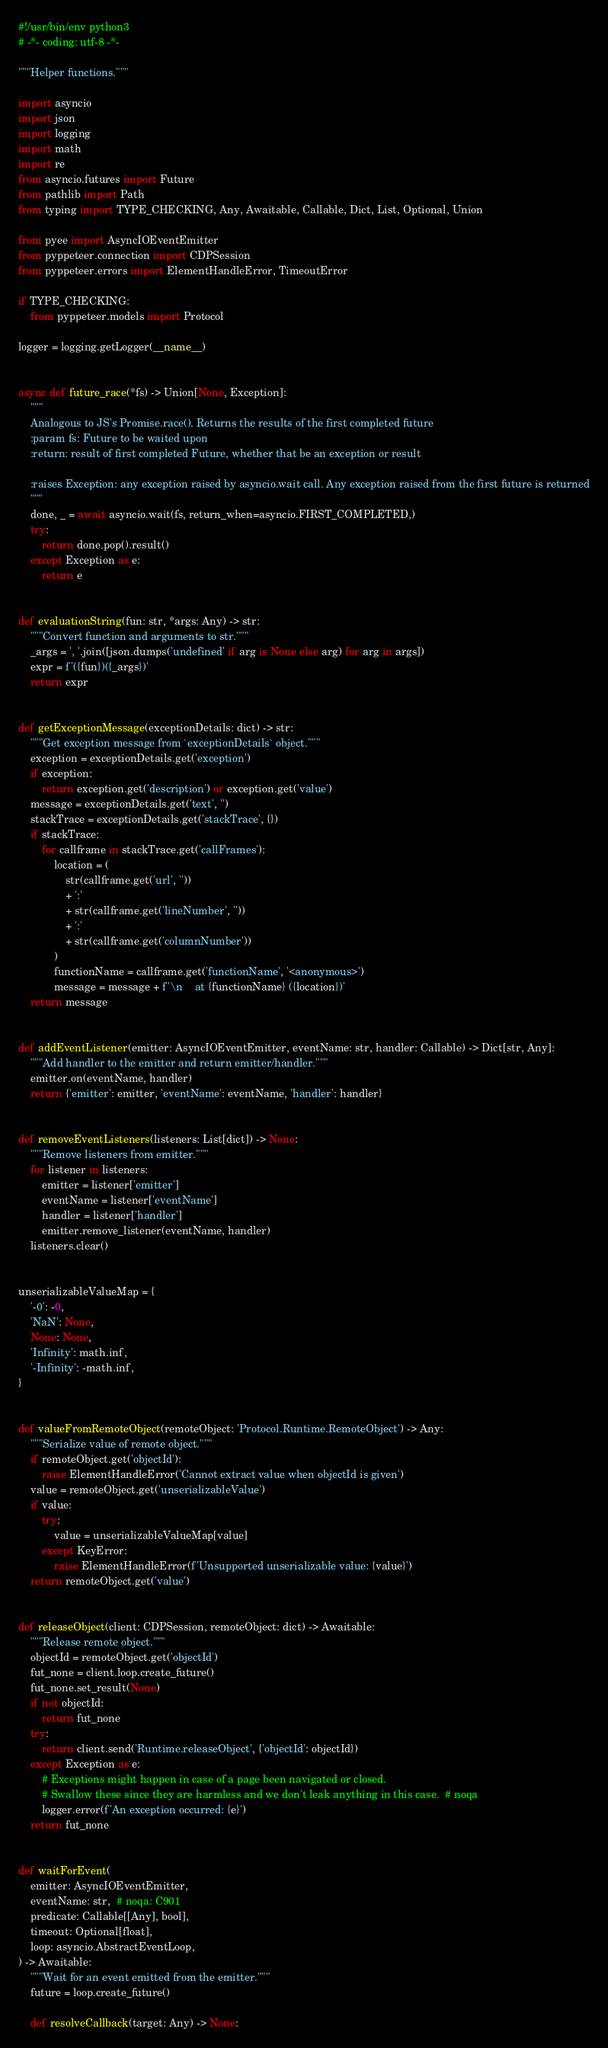Convert code to text. <code><loc_0><loc_0><loc_500><loc_500><_Python_>#!/usr/bin/env python3
# -*- coding: utf-8 -*-

"""Helper functions."""

import asyncio
import json
import logging
import math
import re
from asyncio.futures import Future
from pathlib import Path
from typing import TYPE_CHECKING, Any, Awaitable, Callable, Dict, List, Optional, Union

from pyee import AsyncIOEventEmitter
from pyppeteer.connection import CDPSession
from pyppeteer.errors import ElementHandleError, TimeoutError

if TYPE_CHECKING:
    from pyppeteer.models import Protocol

logger = logging.getLogger(__name__)


async def future_race(*fs) -> Union[None, Exception]:
    """
    Analogous to JS's Promise.race(). Returns the results of the first completed future
    :param fs: Future to be waited upon
    :return: result of first completed Future, whether that be an exception or result

    :raises Exception: any exception raised by asyncio.wait call. Any exception raised from the first future is returned
    """
    done, _ = await asyncio.wait(fs, return_when=asyncio.FIRST_COMPLETED,)
    try:
        return done.pop().result()
    except Exception as e:
        return e


def evaluationString(fun: str, *args: Any) -> str:
    """Convert function and arguments to str."""
    _args = ', '.join([json.dumps('undefined' if arg is None else arg) for arg in args])
    expr = f'({fun})({_args})'
    return expr


def getExceptionMessage(exceptionDetails: dict) -> str:
    """Get exception message from `exceptionDetails` object."""
    exception = exceptionDetails.get('exception')
    if exception:
        return exception.get('description') or exception.get('value')
    message = exceptionDetails.get('text', '')
    stackTrace = exceptionDetails.get('stackTrace', {})
    if stackTrace:
        for callframe in stackTrace.get('callFrames'):
            location = (
                str(callframe.get('url', ''))
                + ':'
                + str(callframe.get('lineNumber', ''))
                + ':'
                + str(callframe.get('columnNumber'))
            )
            functionName = callframe.get('functionName', '<anonymous>')
            message = message + f'\n    at {functionName} ({location})'
    return message


def addEventListener(emitter: AsyncIOEventEmitter, eventName: str, handler: Callable) -> Dict[str, Any]:
    """Add handler to the emitter and return emitter/handler."""
    emitter.on(eventName, handler)
    return {'emitter': emitter, 'eventName': eventName, 'handler': handler}


def removeEventListeners(listeners: List[dict]) -> None:
    """Remove listeners from emitter."""
    for listener in listeners:
        emitter = listener['emitter']
        eventName = listener['eventName']
        handler = listener['handler']
        emitter.remove_listener(eventName, handler)
    listeners.clear()


unserializableValueMap = {
    '-0': -0,
    'NaN': None,
    None: None,
    'Infinity': math.inf,
    '-Infinity': -math.inf,
}


def valueFromRemoteObject(remoteObject: 'Protocol.Runtime.RemoteObject') -> Any:
    """Serialize value of remote object."""
    if remoteObject.get('objectId'):
        raise ElementHandleError('Cannot extract value when objectId is given')
    value = remoteObject.get('unserializableValue')
    if value:
        try:
            value = unserializableValueMap[value]
        except KeyError:
            raise ElementHandleError(f'Unsupported unserializable value: {value}')
    return remoteObject.get('value')


def releaseObject(client: CDPSession, remoteObject: dict) -> Awaitable:
    """Release remote object."""
    objectId = remoteObject.get('objectId')
    fut_none = client.loop.create_future()
    fut_none.set_result(None)
    if not objectId:
        return fut_none
    try:
        return client.send('Runtime.releaseObject', {'objectId': objectId})
    except Exception as e:
        # Exceptions might happen in case of a page been navigated or closed.
        # Swallow these since they are harmless and we don't leak anything in this case.  # noqa
        logger.error(f'An exception occurred: {e}')
    return fut_none


def waitForEvent(
    emitter: AsyncIOEventEmitter,
    eventName: str,  # noqa: C901
    predicate: Callable[[Any], bool],
    timeout: Optional[float],
    loop: asyncio.AbstractEventLoop,
) -> Awaitable:
    """Wait for an event emitted from the emitter."""
    future = loop.create_future()

    def resolveCallback(target: Any) -> None:</code> 